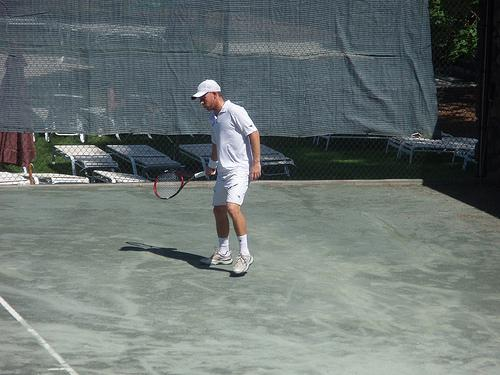Question: what sport is being played?
Choices:
A. Football.
B. Soccer.
C. Basketball.
D. Tennis.
Answer with the letter. Answer: D Question: what color hat is the person wearing?
Choices:
A. Blue.
B. White.
C. Black.
D. Red.
Answer with the letter. Answer: B 